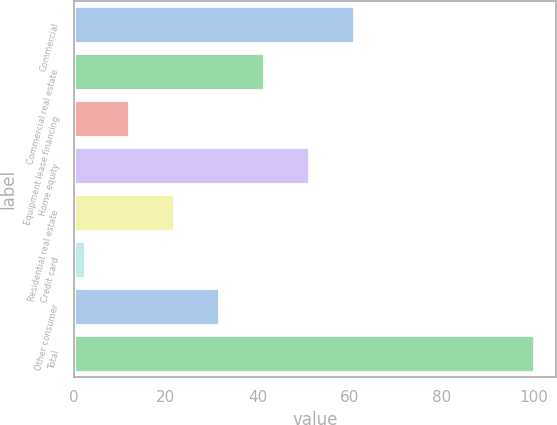Convert chart. <chart><loc_0><loc_0><loc_500><loc_500><bar_chart><fcel>Commercial<fcel>Commercial real estate<fcel>Equipment lease financing<fcel>Home equity<fcel>Residential real estate<fcel>Credit card<fcel>Other consumer<fcel>Total<nl><fcel>60.92<fcel>41.38<fcel>12.07<fcel>51.15<fcel>21.84<fcel>2.3<fcel>31.61<fcel>100<nl></chart> 